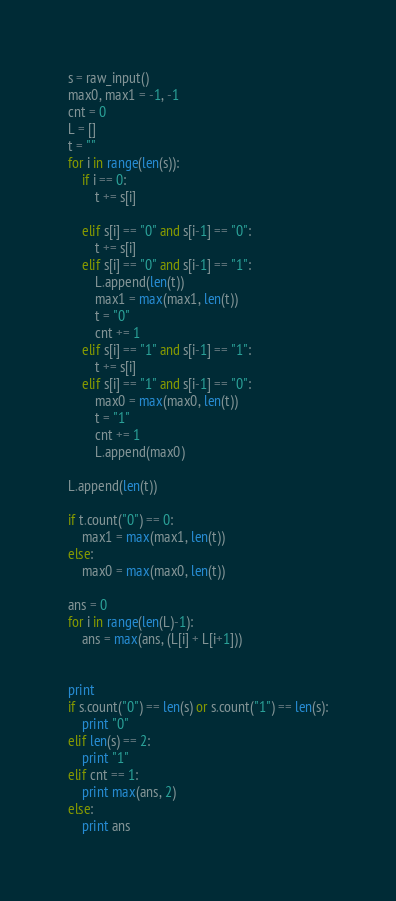Convert code to text. <code><loc_0><loc_0><loc_500><loc_500><_Python_>s = raw_input()
max0, max1 = -1, -1
cnt = 0
L = []
t = ""
for i in range(len(s)):
    if i == 0:
        t += s[i]
    
    elif s[i] == "0" and s[i-1] == "0":
        t += s[i]
    elif s[i] == "0" and s[i-1] == "1":
        L.append(len(t))
        max1 = max(max1, len(t))
        t = "0" 
        cnt += 1
    elif s[i] == "1" and s[i-1] == "1":
        t += s[i]
    elif s[i] == "1" and s[i-1] == "0":
        max0 = max(max0, len(t))
        t = "1"
        cnt += 1
        L.append(max0)

L.append(len(t))

if t.count("0") == 0:
    max1 = max(max1, len(t))
else:
    max0 = max(max0, len(t))

ans = 0
for i in range(len(L)-1):
    ans = max(ans, (L[i] + L[i+1]))


print 
if s.count("0") == len(s) or s.count("1") == len(s):
    print "0"
elif len(s) == 2:
    print "1"
elif cnt == 1:
    print max(ans, 2)
else:
    print ans
</code> 